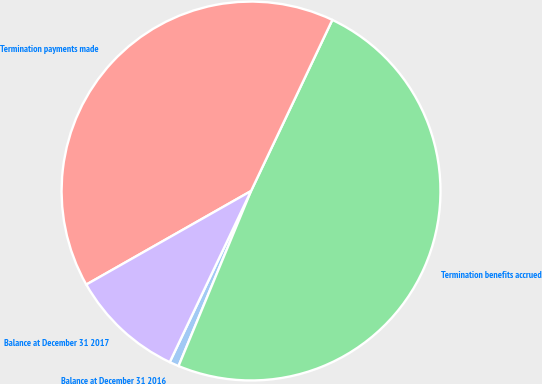Convert chart. <chart><loc_0><loc_0><loc_500><loc_500><pie_chart><fcel>Balance at December 31 2016<fcel>Termination benefits accrued<fcel>Termination payments made<fcel>Balance at December 31 2017<nl><fcel>0.81%<fcel>49.19%<fcel>40.28%<fcel>9.72%<nl></chart> 